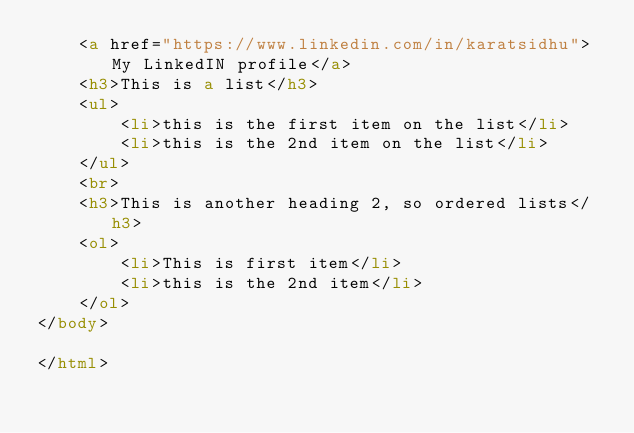<code> <loc_0><loc_0><loc_500><loc_500><_HTML_>    <a href="https://www.linkedin.com/in/karatsidhu">My LinkedIN profile</a>
    <h3>This is a list</h3>
    <ul>
        <li>this is the first item on the list</li>
        <li>this is the 2nd item on the list</li>
    </ul>
    <br>
    <h3>This is another heading 2, so ordered lists</h3>
    <ol>
        <li>This is first item</li>
        <li>this is the 2nd item</li>
    </ol>
</body>

</html></code> 